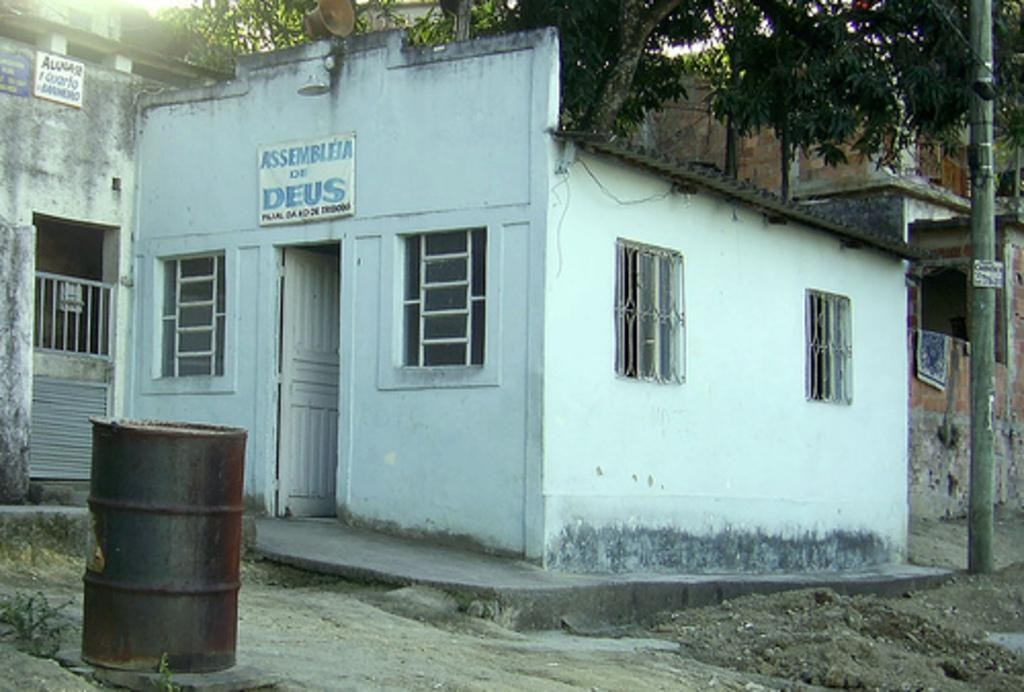<image>
Write a terse but informative summary of the picture. The Assembleia de Deus is small white building. 